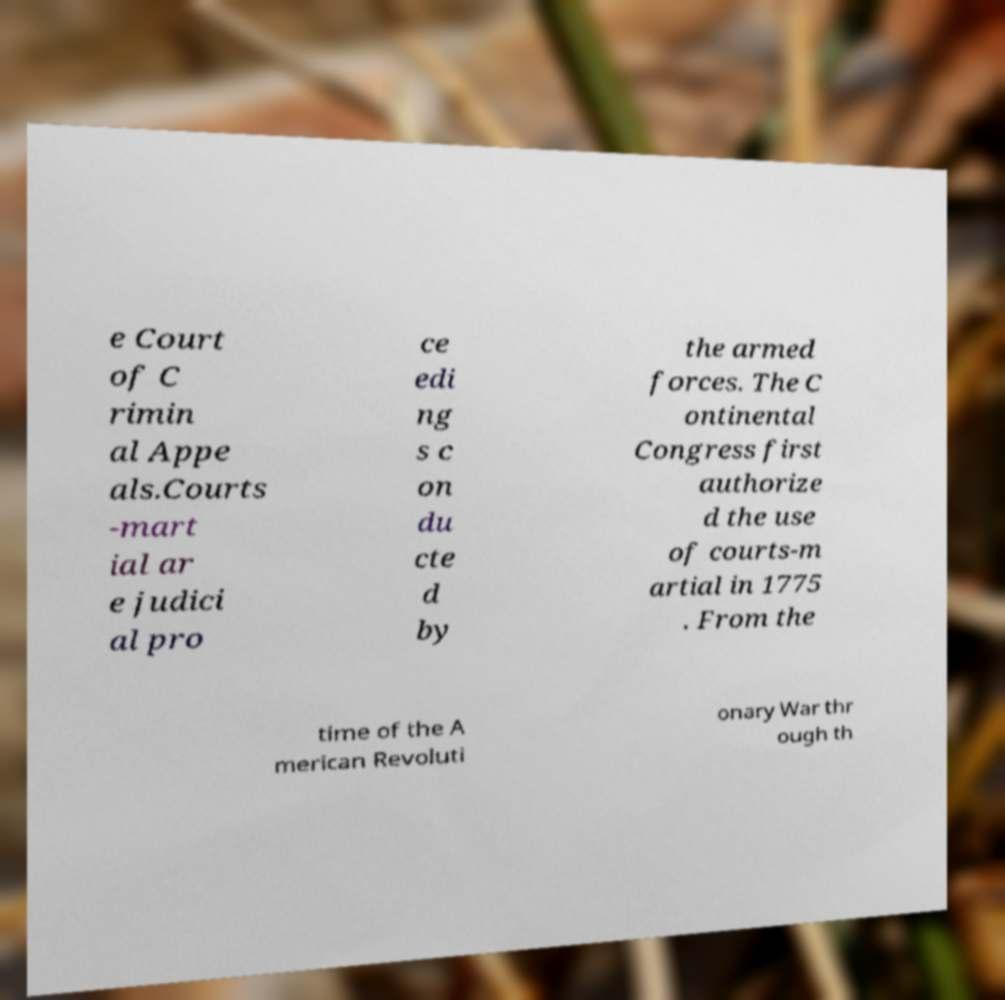Could you extract and type out the text from this image? e Court of C rimin al Appe als.Courts -mart ial ar e judici al pro ce edi ng s c on du cte d by the armed forces. The C ontinental Congress first authorize d the use of courts-m artial in 1775 . From the time of the A merican Revoluti onary War thr ough th 